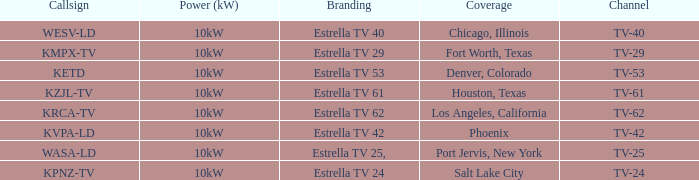List the branding name for channel tv-62. Estrella TV 62. 